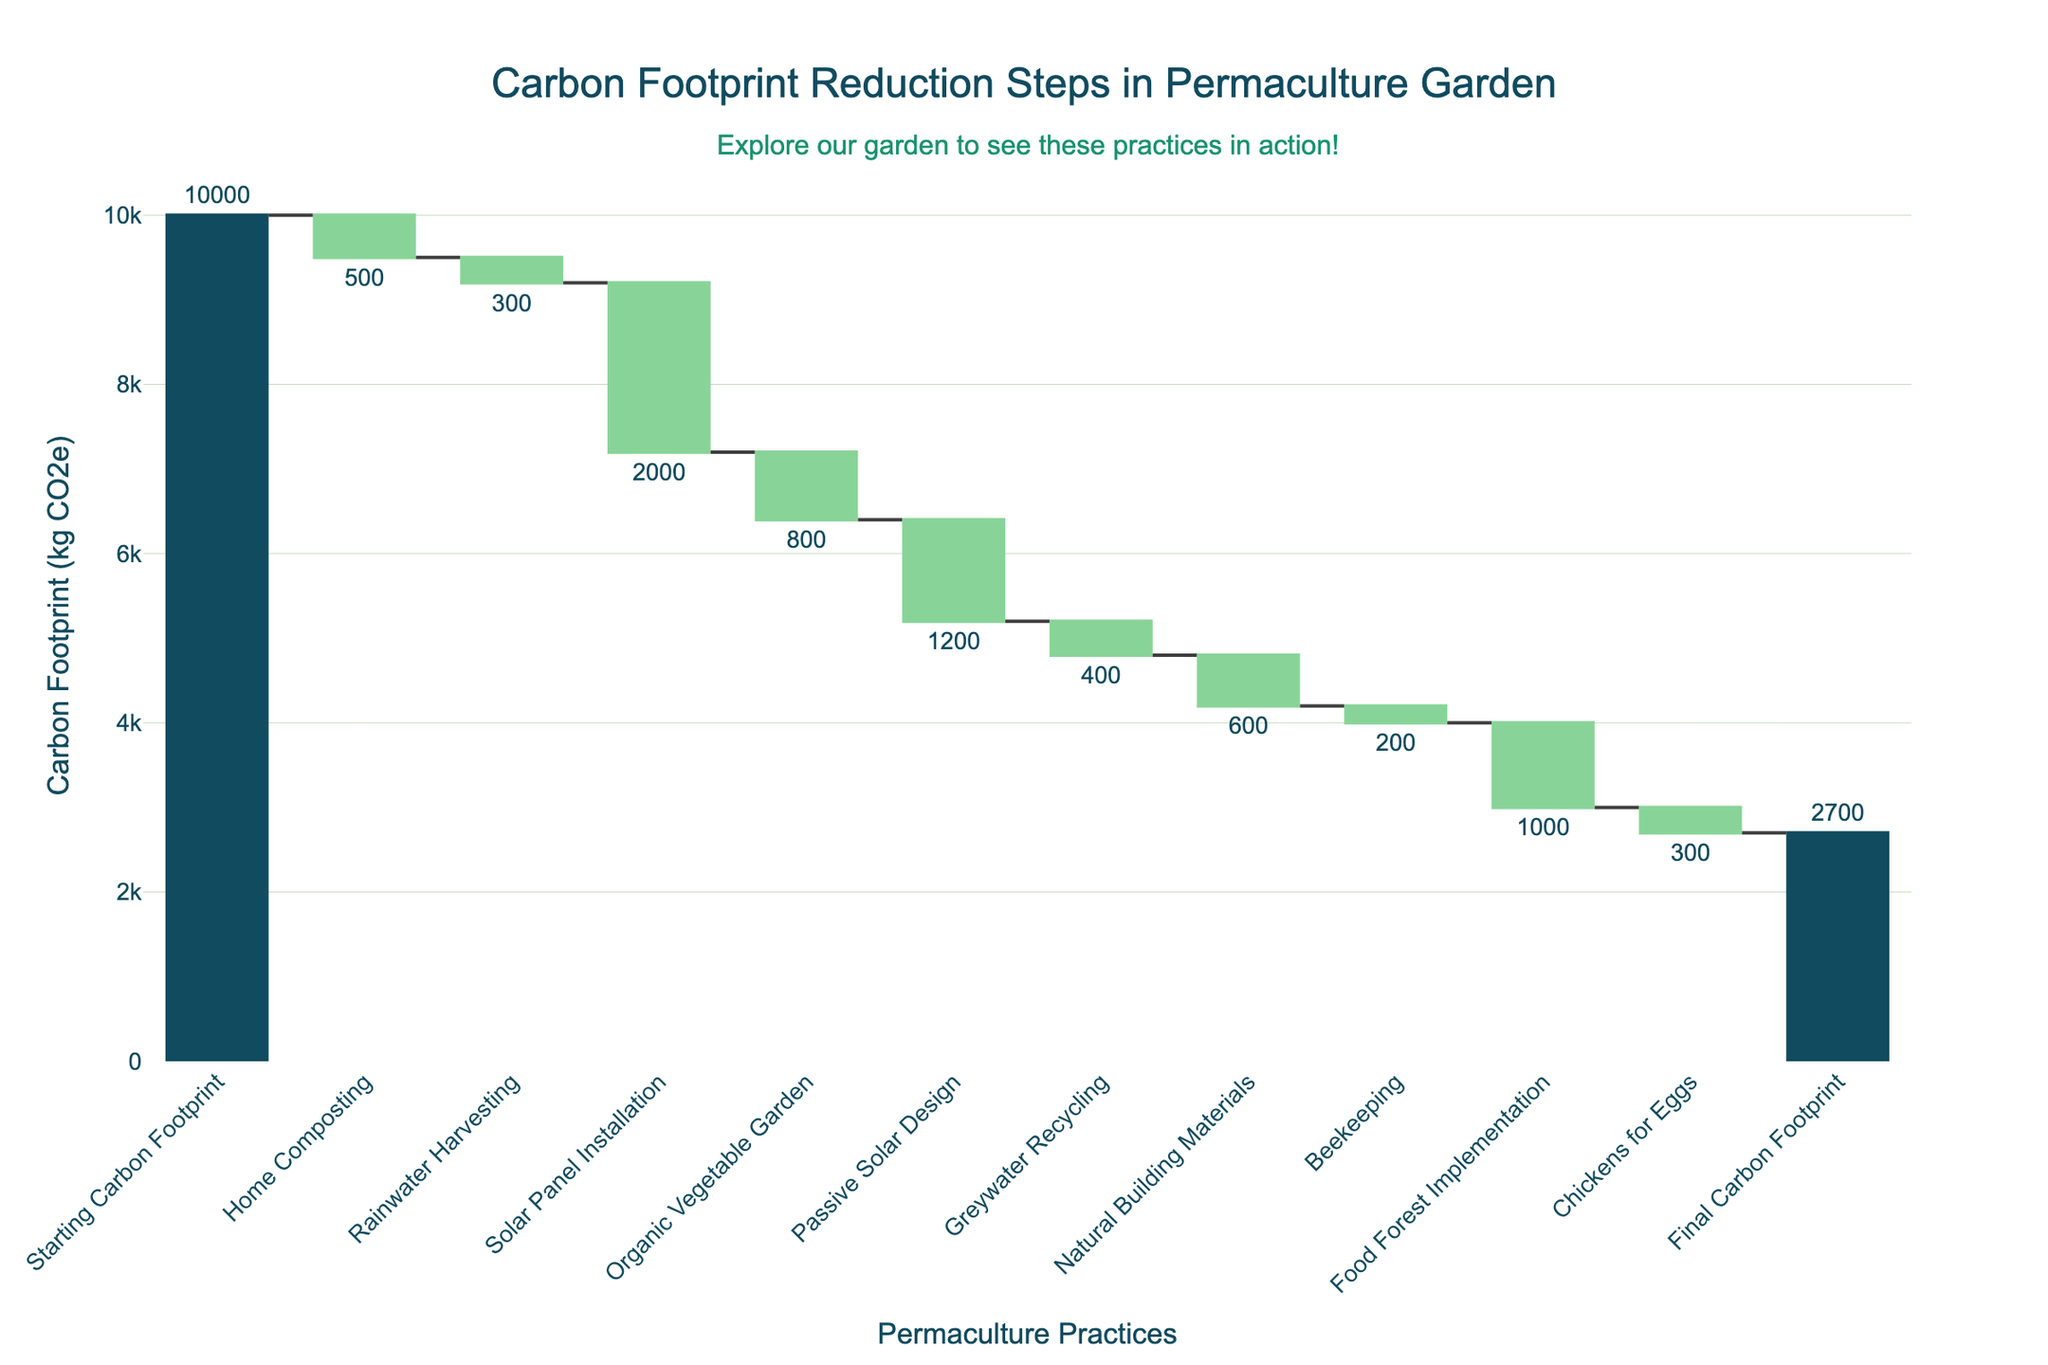What's the initial carbon footprint value? The starting point of the waterfall chart is labeled "Starting Carbon Footprint," and its value is indicated at the top of the first bar.
Answer: 10,000 kg CO2e What is the final carbon footprint value after all the reductions? The final value is labeled "Final Carbon Footprint" and shown at the top of the last bar.
Answer: 2,700 kg CO2e How much carbon footprint is reduced by home composting? Look for the "Home Composting" category and note its value.
Answer: 500 kg CO2e Which practice contributes the most to reducing the carbon footprint? Compare the lengths and values of all the reduction steps. Solar Panel Installation has the largest reduction value.
Answer: Solar Panel Installation How much total carbon footprint reduction is achieved by Food Forest Implementation and Chickens for Eggs combined? Sum the values of "Food Forest Implementation" and "Chickens for Eggs."
Answer: 1,300 kg CO2e What is the difference in carbon footprint reduction between Rainwater Harvesting and Greywater Recycling? Find the values for "Rainwater Harvesting" and "Greywater Recycling" and subtract one from the other.
Answer: 100 kg CO2e How many different permaculture practices are involved in reducing the carbon footprint? Count the number of categories listed, excluding the starting and final values.
Answer: 10 practices Which carbon reduction practice has the least impact? Identify the category with the smallest reduction value. Beekeeping has the smallest value.
Answer: Beekeeping What is the total reduction in carbon footprint from all the practices combined? Sum all the listed reductions. The total reduction is 7,300 kg CO2e (500 + 300 + 2000 + 800 + 1200 + 400 + 600 + 200 + 1000 + 300).
Answer: 7,300 kg CO2e How does the value of "Organic Vegetable Garden" compare to "Passive Solar Design"? Compare the values of these two categories. "Passive Solar Design" has a greater reduction than "Organic Vegetable Garden."
Answer: Passive Solar Design > Organic Vegetable Garden 